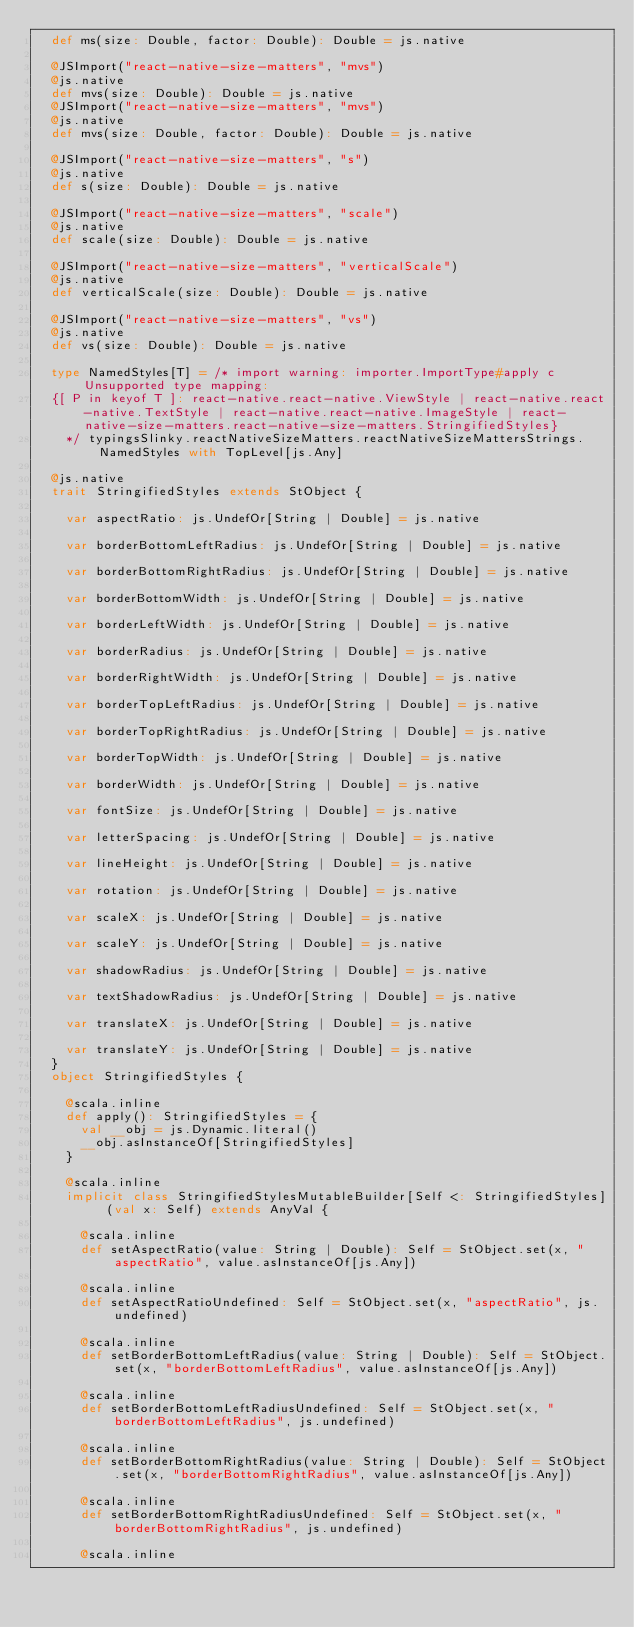Convert code to text. <code><loc_0><loc_0><loc_500><loc_500><_Scala_>  def ms(size: Double, factor: Double): Double = js.native
  
  @JSImport("react-native-size-matters", "mvs")
  @js.native
  def mvs(size: Double): Double = js.native
  @JSImport("react-native-size-matters", "mvs")
  @js.native
  def mvs(size: Double, factor: Double): Double = js.native
  
  @JSImport("react-native-size-matters", "s")
  @js.native
  def s(size: Double): Double = js.native
  
  @JSImport("react-native-size-matters", "scale")
  @js.native
  def scale(size: Double): Double = js.native
  
  @JSImport("react-native-size-matters", "verticalScale")
  @js.native
  def verticalScale(size: Double): Double = js.native
  
  @JSImport("react-native-size-matters", "vs")
  @js.native
  def vs(size: Double): Double = js.native
  
  type NamedStyles[T] = /* import warning: importer.ImportType#apply c Unsupported type mapping: 
  {[ P in keyof T ]: react-native.react-native.ViewStyle | react-native.react-native.TextStyle | react-native.react-native.ImageStyle | react-native-size-matters.react-native-size-matters.StringifiedStyles}
    */ typingsSlinky.reactNativeSizeMatters.reactNativeSizeMattersStrings.NamedStyles with TopLevel[js.Any]
  
  @js.native
  trait StringifiedStyles extends StObject {
    
    var aspectRatio: js.UndefOr[String | Double] = js.native
    
    var borderBottomLeftRadius: js.UndefOr[String | Double] = js.native
    
    var borderBottomRightRadius: js.UndefOr[String | Double] = js.native
    
    var borderBottomWidth: js.UndefOr[String | Double] = js.native
    
    var borderLeftWidth: js.UndefOr[String | Double] = js.native
    
    var borderRadius: js.UndefOr[String | Double] = js.native
    
    var borderRightWidth: js.UndefOr[String | Double] = js.native
    
    var borderTopLeftRadius: js.UndefOr[String | Double] = js.native
    
    var borderTopRightRadius: js.UndefOr[String | Double] = js.native
    
    var borderTopWidth: js.UndefOr[String | Double] = js.native
    
    var borderWidth: js.UndefOr[String | Double] = js.native
    
    var fontSize: js.UndefOr[String | Double] = js.native
    
    var letterSpacing: js.UndefOr[String | Double] = js.native
    
    var lineHeight: js.UndefOr[String | Double] = js.native
    
    var rotation: js.UndefOr[String | Double] = js.native
    
    var scaleX: js.UndefOr[String | Double] = js.native
    
    var scaleY: js.UndefOr[String | Double] = js.native
    
    var shadowRadius: js.UndefOr[String | Double] = js.native
    
    var textShadowRadius: js.UndefOr[String | Double] = js.native
    
    var translateX: js.UndefOr[String | Double] = js.native
    
    var translateY: js.UndefOr[String | Double] = js.native
  }
  object StringifiedStyles {
    
    @scala.inline
    def apply(): StringifiedStyles = {
      val __obj = js.Dynamic.literal()
      __obj.asInstanceOf[StringifiedStyles]
    }
    
    @scala.inline
    implicit class StringifiedStylesMutableBuilder[Self <: StringifiedStyles] (val x: Self) extends AnyVal {
      
      @scala.inline
      def setAspectRatio(value: String | Double): Self = StObject.set(x, "aspectRatio", value.asInstanceOf[js.Any])
      
      @scala.inline
      def setAspectRatioUndefined: Self = StObject.set(x, "aspectRatio", js.undefined)
      
      @scala.inline
      def setBorderBottomLeftRadius(value: String | Double): Self = StObject.set(x, "borderBottomLeftRadius", value.asInstanceOf[js.Any])
      
      @scala.inline
      def setBorderBottomLeftRadiusUndefined: Self = StObject.set(x, "borderBottomLeftRadius", js.undefined)
      
      @scala.inline
      def setBorderBottomRightRadius(value: String | Double): Self = StObject.set(x, "borderBottomRightRadius", value.asInstanceOf[js.Any])
      
      @scala.inline
      def setBorderBottomRightRadiusUndefined: Self = StObject.set(x, "borderBottomRightRadius", js.undefined)
      
      @scala.inline</code> 